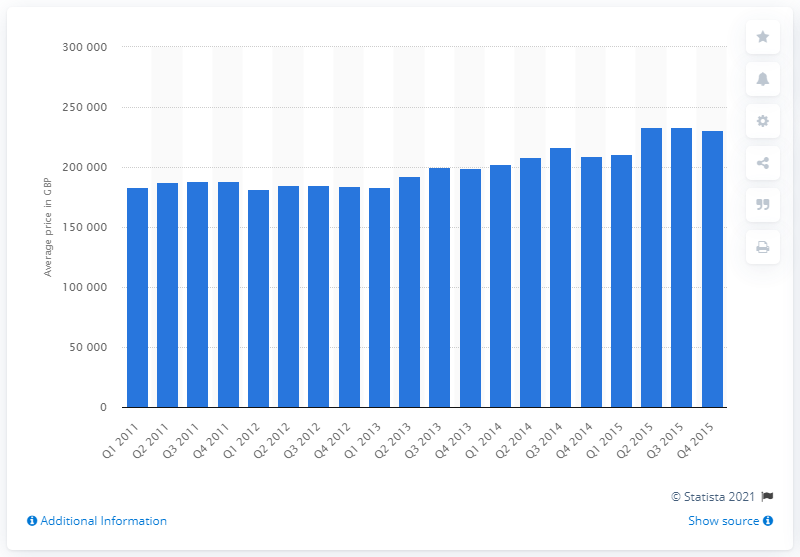Highlight a few significant elements in this photo. The average price of a bungalow in the quarter ending June 2015 was approximately 233,385. 